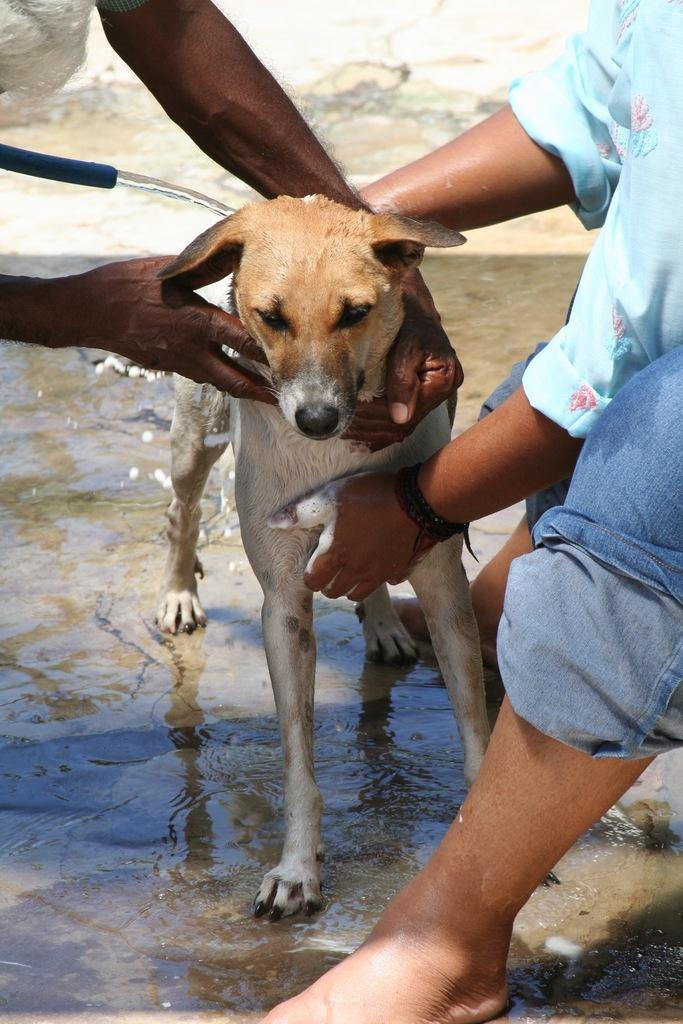What type of animal is present in the image? There is a dog in the image. Are there any humans in the image? Yes, there are people in the image. What are the people doing in the image? The people are cleaning the dog. How many toes does the dog have on its front paw in the image? The number of toes on the dog's front paw cannot be determined from the image. 